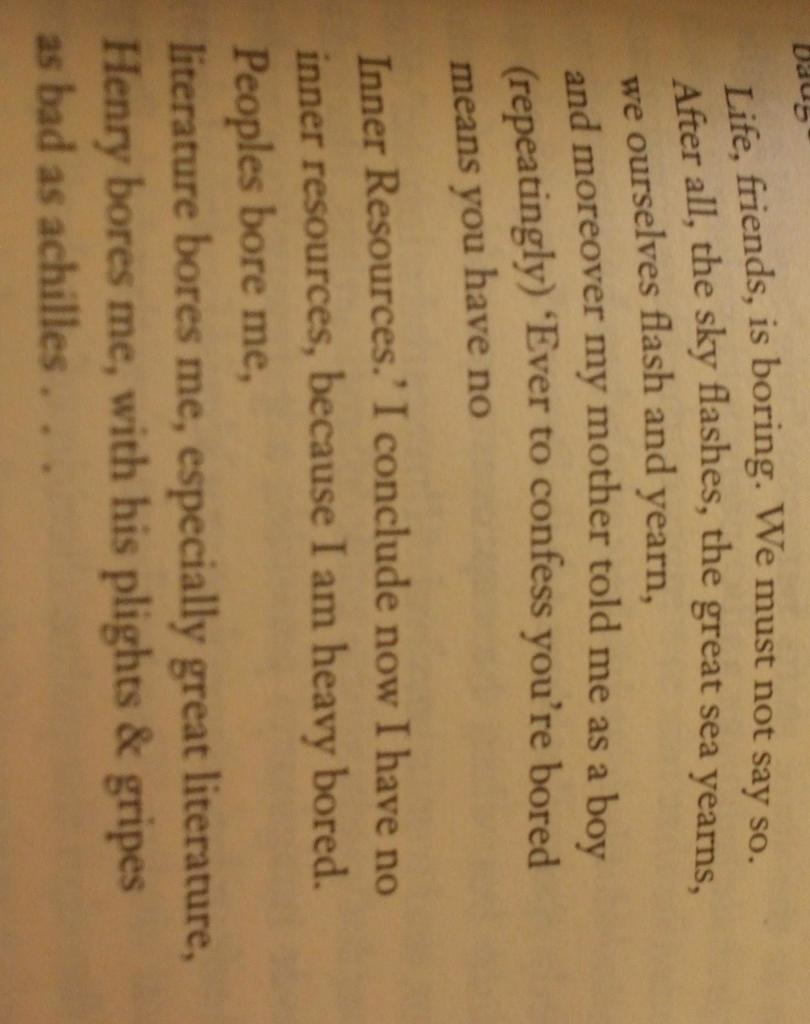<image>
Summarize the visual content of the image. An interesting phrase from this paragraph is "People bore me". 